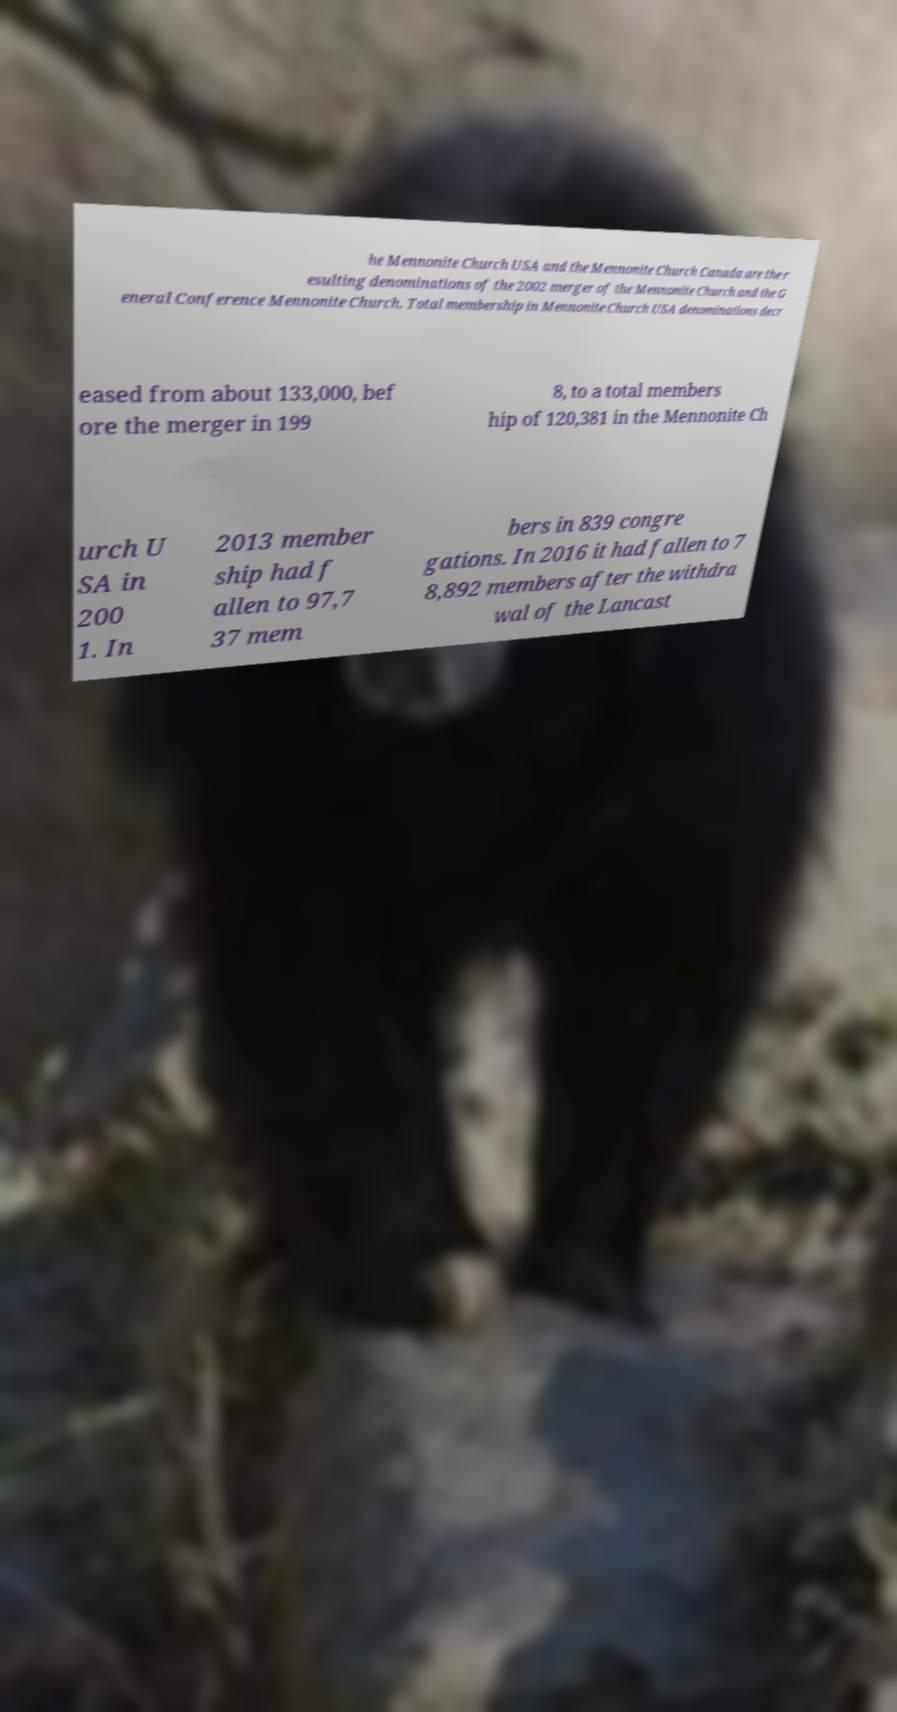I need the written content from this picture converted into text. Can you do that? he Mennonite Church USA and the Mennonite Church Canada are the r esulting denominations of the 2002 merger of the Mennonite Church and the G eneral Conference Mennonite Church. Total membership in Mennonite Church USA denominations decr eased from about 133,000, bef ore the merger in 199 8, to a total members hip of 120,381 in the Mennonite Ch urch U SA in 200 1. In 2013 member ship had f allen to 97,7 37 mem bers in 839 congre gations. In 2016 it had fallen to 7 8,892 members after the withdra wal of the Lancast 